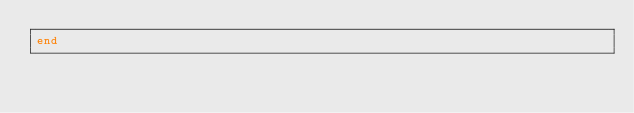Convert code to text. <code><loc_0><loc_0><loc_500><loc_500><_Ruby_>end


</code> 